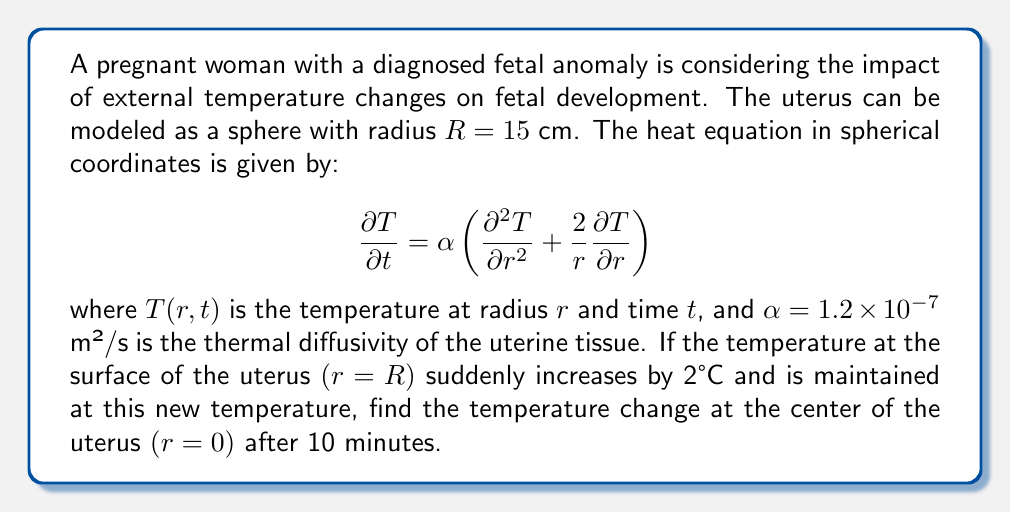Teach me how to tackle this problem. To solve this problem, we need to use the solution for the heat equation in a sphere with a sudden surface temperature change. The solution is given by:

$$T(r,t) - T_0 = \Delta T \left(1 + \frac{2R}{\pi r}\sum_{n=1}^{\infty}\frac{(-1)^n}{n}\sin\left(\frac{n\pi r}{R}\right)e^{-\alpha n^2\pi^2t/R^2}\right)$$

where $T_0$ is the initial temperature, $\Delta T$ is the temperature change at the surface, and $r$ is the radial distance from the center.

Given:
- $R = 15$ cm $= 0.15$ m
- $\alpha = 1.2 \times 10^{-7}$ m²/s
- $\Delta T = 2°C$
- $t = 10$ minutes $= 600$ s
- We want to find the temperature change at $r = 0$ (center)

Steps:
1) At $r = 0$, $\sin(0) = 0$, so the sum in the equation becomes zero.
2) The equation simplifies to:
   $$T(0,t) - T_0 = \Delta T \left(1 + \frac{2R}{\pi \cdot 0}\sum_{n=1}^{\infty}\frac{(-1)^n}{n} \cdot 0\right) = \Delta T$$

3) Calculate the Fourier number $Fo = \frac{\alpha t}{R^2}$:
   $$Fo = \frac{(1.2 \times 10^{-7})(600)}{(0.15)^2} = 0.032$$

4) Since $Fo < 0.2$, we need to use more terms in the series for accuracy. Let's use the first 5 terms:

   $$T(0,t) - T_0 = 2 \left(1 - \frac{2}{\pi}\sum_{n=1}^{5}\frac{(-1)^{n+1}}{n}e^{-n^2\pi^2Fo}\right)$$

5) Calculate each term:
   n=1: $\frac{2}{\pi} \cdot 1 \cdot e^{-\pi^2(0.032)} = 0.5640$
   n=2: $\frac{2}{\pi} \cdot \frac{1}{2} \cdot e^{-4\pi^2(0.032)} = 0.1266$
   n=3: $\frac{2}{\pi} \cdot \frac{1}{3} \cdot e^{-9\pi^2(0.032)} = 0.0168$
   n=4: $\frac{2}{\pi} \cdot \frac{1}{4} \cdot e^{-16\pi^2(0.032)} = 0.0013$
   n=5: $\frac{2}{\pi} \cdot \frac{1}{5} \cdot e^{-25\pi^2(0.032)} = 0.0001$

6) Sum the terms: 0.5640 - 0.1266 + 0.0168 - 0.0013 + 0.0001 = 0.4530

7) Final calculation:
   $$T(0,t) - T_0 = 2(1 - 0.4530) = 1.094°C$$
Answer: The temperature change at the center of the uterus after 10 minutes is approximately $1.09°C$. 